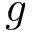<formula> <loc_0><loc_0><loc_500><loc_500>g</formula> 